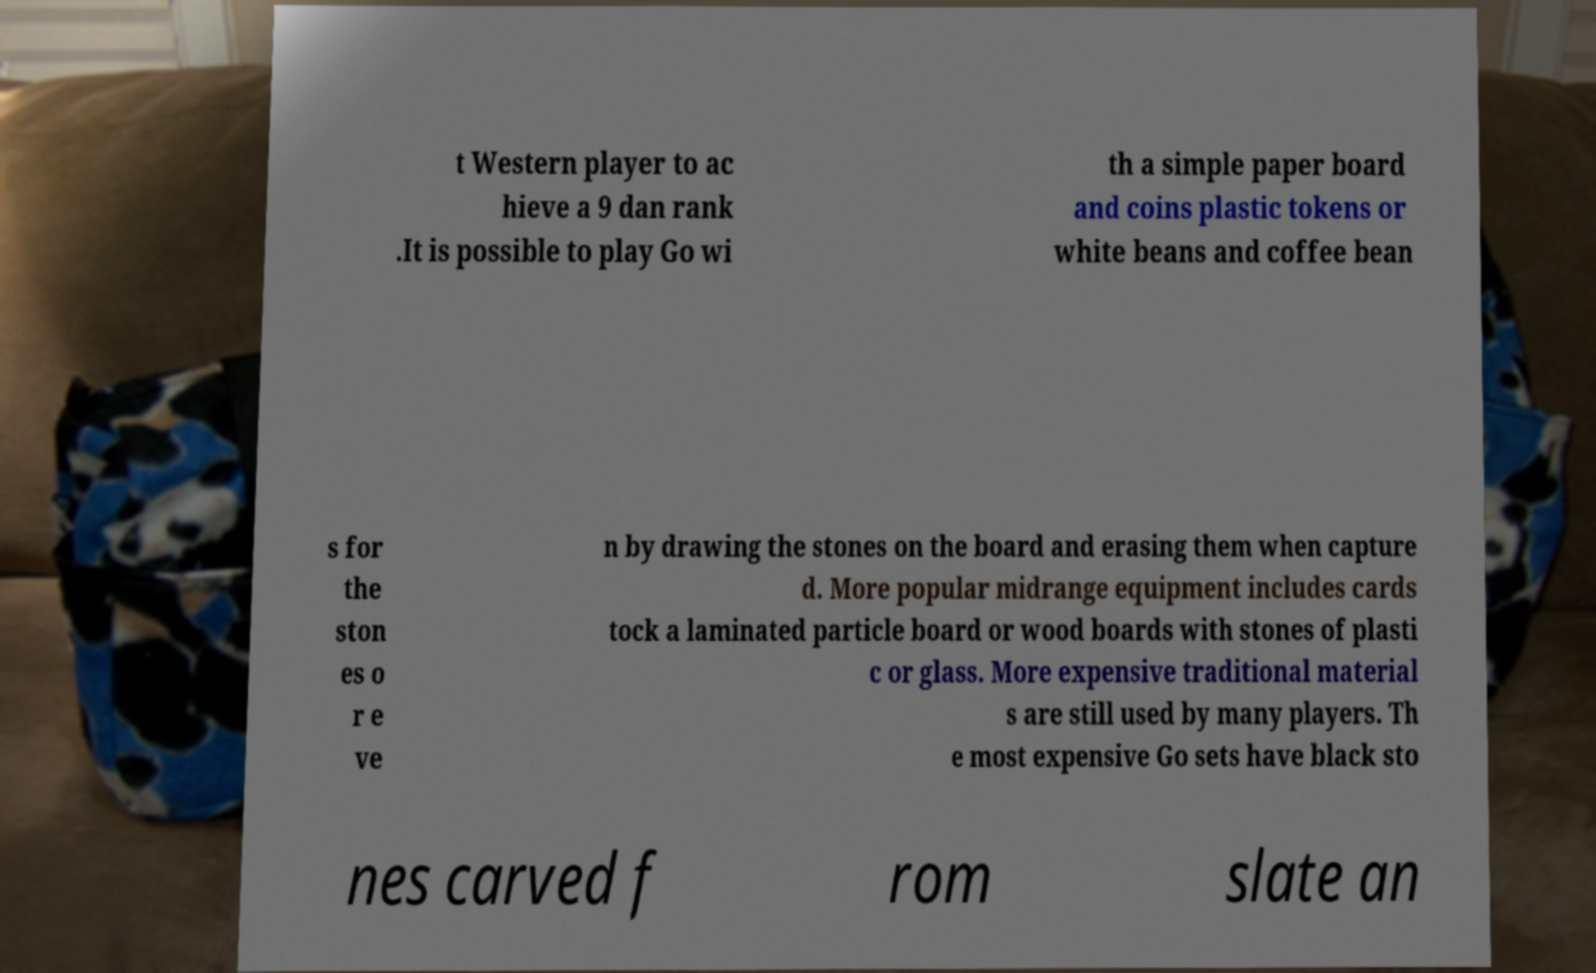Please read and relay the text visible in this image. What does it say? t Western player to ac hieve a 9 dan rank .It is possible to play Go wi th a simple paper board and coins plastic tokens or white beans and coffee bean s for the ston es o r e ve n by drawing the stones on the board and erasing them when capture d. More popular midrange equipment includes cards tock a laminated particle board or wood boards with stones of plasti c or glass. More expensive traditional material s are still used by many players. Th e most expensive Go sets have black sto nes carved f rom slate an 